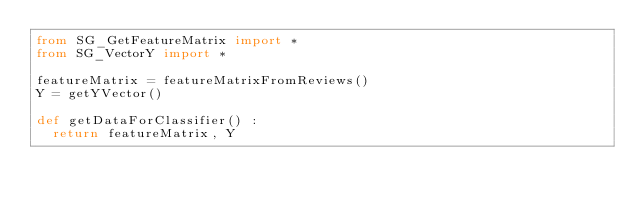<code> <loc_0><loc_0><loc_500><loc_500><_Python_>from SG_GetFeatureMatrix import *
from SG_VectorY import *

featureMatrix = featureMatrixFromReviews()
Y = getYVector()

def getDataForClassifier() :
	return featureMatrix, Y</code> 